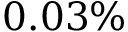Convert formula to latex. <formula><loc_0><loc_0><loc_500><loc_500>0 . 0 3 \%</formula> 